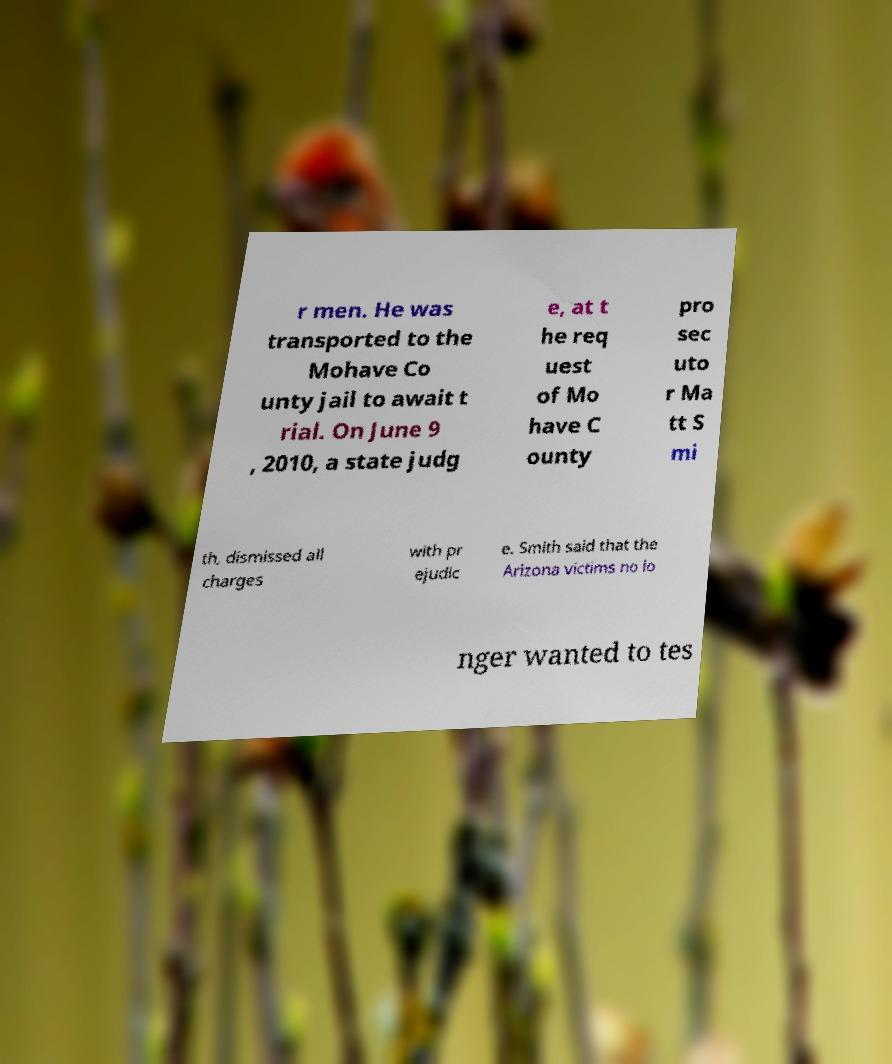What messages or text are displayed in this image? I need them in a readable, typed format. r men. He was transported to the Mohave Co unty jail to await t rial. On June 9 , 2010, a state judg e, at t he req uest of Mo have C ounty pro sec uto r Ma tt S mi th, dismissed all charges with pr ejudic e. Smith said that the Arizona victims no lo nger wanted to tes 